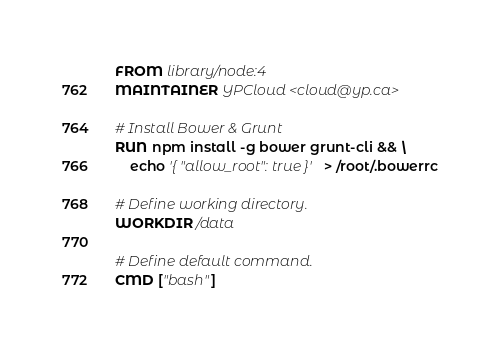Convert code to text. <code><loc_0><loc_0><loc_500><loc_500><_Dockerfile_>FROM library/node:4
MAINTAINER YPCloud <cloud@yp.ca>

# Install Bower & Grunt
RUN npm install -g bower grunt-cli && \
    echo '{ "allow_root": true }' > /root/.bowerrc

# Define working directory.
WORKDIR /data

# Define default command.
CMD ["bash"]
</code> 